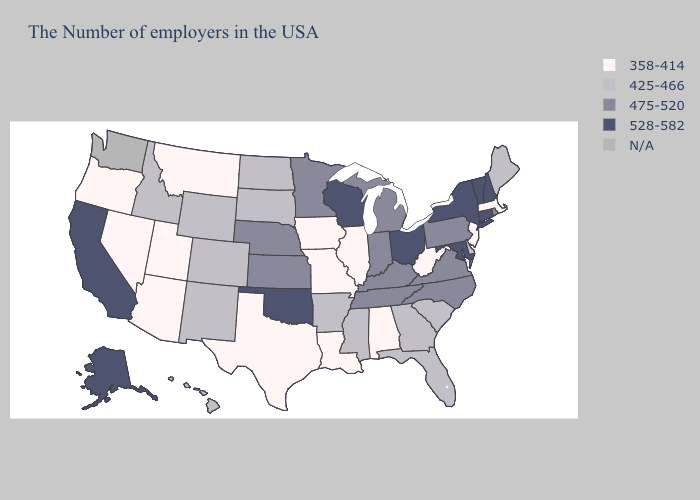Does Illinois have the lowest value in the USA?
Quick response, please. Yes. What is the lowest value in the Northeast?
Quick response, please. 358-414. Name the states that have a value in the range 475-520?
Answer briefly. Rhode Island, Pennsylvania, Virginia, North Carolina, Michigan, Kentucky, Indiana, Tennessee, Minnesota, Kansas, Nebraska. Name the states that have a value in the range 358-414?
Short answer required. Massachusetts, New Jersey, West Virginia, Alabama, Illinois, Louisiana, Missouri, Iowa, Texas, Utah, Montana, Arizona, Nevada, Oregon. Name the states that have a value in the range 425-466?
Keep it brief. Maine, Delaware, South Carolina, Florida, Georgia, Mississippi, Arkansas, South Dakota, North Dakota, Wyoming, Colorado, New Mexico, Idaho, Hawaii. What is the highest value in the USA?
Answer briefly. 528-582. Is the legend a continuous bar?
Answer briefly. No. What is the value of Illinois?
Give a very brief answer. 358-414. Name the states that have a value in the range 358-414?
Concise answer only. Massachusetts, New Jersey, West Virginia, Alabama, Illinois, Louisiana, Missouri, Iowa, Texas, Utah, Montana, Arizona, Nevada, Oregon. Which states have the lowest value in the USA?
Answer briefly. Massachusetts, New Jersey, West Virginia, Alabama, Illinois, Louisiana, Missouri, Iowa, Texas, Utah, Montana, Arizona, Nevada, Oregon. What is the value of New York?
Be succinct. 528-582. What is the lowest value in the USA?
Answer briefly. 358-414. What is the value of California?
Short answer required. 528-582. What is the highest value in the MidWest ?
Answer briefly. 528-582. Which states have the lowest value in the Northeast?
Quick response, please. Massachusetts, New Jersey. 